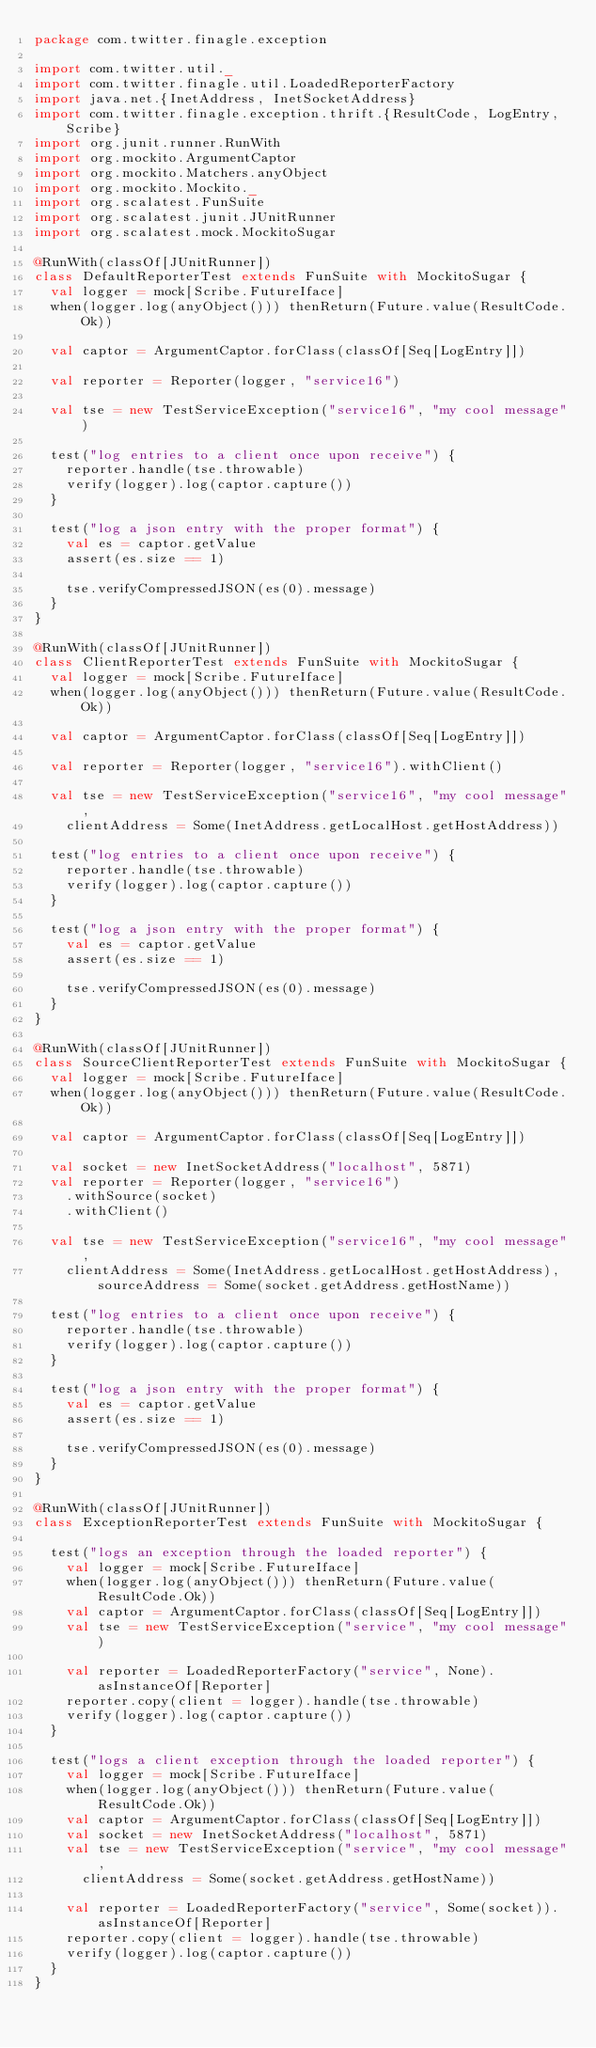<code> <loc_0><loc_0><loc_500><loc_500><_Scala_>package com.twitter.finagle.exception

import com.twitter.util._
import com.twitter.finagle.util.LoadedReporterFactory
import java.net.{InetAddress, InetSocketAddress}
import com.twitter.finagle.exception.thrift.{ResultCode, LogEntry, Scribe}
import org.junit.runner.RunWith
import org.mockito.ArgumentCaptor
import org.mockito.Matchers.anyObject
import org.mockito.Mockito._
import org.scalatest.FunSuite
import org.scalatest.junit.JUnitRunner
import org.scalatest.mock.MockitoSugar

@RunWith(classOf[JUnitRunner])
class DefaultReporterTest extends FunSuite with MockitoSugar {
  val logger = mock[Scribe.FutureIface]
  when(logger.log(anyObject())) thenReturn(Future.value(ResultCode.Ok))

  val captor = ArgumentCaptor.forClass(classOf[Seq[LogEntry]])

  val reporter = Reporter(logger, "service16")

  val tse = new TestServiceException("service16", "my cool message")

  test("log entries to a client once upon receive") {
    reporter.handle(tse.throwable)
    verify(logger).log(captor.capture())
  }

  test("log a json entry with the proper format") {
    val es = captor.getValue
    assert(es.size == 1)

    tse.verifyCompressedJSON(es(0).message)
  }
}

@RunWith(classOf[JUnitRunner])
class ClientReporterTest extends FunSuite with MockitoSugar {
  val logger = mock[Scribe.FutureIface]
  when(logger.log(anyObject())) thenReturn(Future.value(ResultCode.Ok))

  val captor = ArgumentCaptor.forClass(classOf[Seq[LogEntry]])

  val reporter = Reporter(logger, "service16").withClient()

  val tse = new TestServiceException("service16", "my cool message",
    clientAddress = Some(InetAddress.getLocalHost.getHostAddress))

  test("log entries to a client once upon receive") {
    reporter.handle(tse.throwable)
    verify(logger).log(captor.capture())
  }

  test("log a json entry with the proper format") {
    val es = captor.getValue
    assert(es.size == 1)

    tse.verifyCompressedJSON(es(0).message)
  }
}

@RunWith(classOf[JUnitRunner])
class SourceClientReporterTest extends FunSuite with MockitoSugar {
  val logger = mock[Scribe.FutureIface]
  when(logger.log(anyObject())) thenReturn(Future.value(ResultCode.Ok))

  val captor = ArgumentCaptor.forClass(classOf[Seq[LogEntry]])

  val socket = new InetSocketAddress("localhost", 5871)
  val reporter = Reporter(logger, "service16")
    .withSource(socket)
    .withClient()

  val tse = new TestServiceException("service16", "my cool message",
    clientAddress = Some(InetAddress.getLocalHost.getHostAddress), sourceAddress = Some(socket.getAddress.getHostName))

  test("log entries to a client once upon receive") {
    reporter.handle(tse.throwable)
    verify(logger).log(captor.capture())
  }

  test("log a json entry with the proper format") {
    val es = captor.getValue
    assert(es.size == 1)

    tse.verifyCompressedJSON(es(0).message)
  }
}

@RunWith(classOf[JUnitRunner])
class ExceptionReporterTest extends FunSuite with MockitoSugar {

  test("logs an exception through the loaded reporter") {
    val logger = mock[Scribe.FutureIface]
    when(logger.log(anyObject())) thenReturn(Future.value(ResultCode.Ok))
    val captor = ArgumentCaptor.forClass(classOf[Seq[LogEntry]])
    val tse = new TestServiceException("service", "my cool message")

    val reporter = LoadedReporterFactory("service", None).asInstanceOf[Reporter]
    reporter.copy(client = logger).handle(tse.throwable)
    verify(logger).log(captor.capture())
  }

  test("logs a client exception through the loaded reporter") {
    val logger = mock[Scribe.FutureIface]
    when(logger.log(anyObject())) thenReturn(Future.value(ResultCode.Ok))
    val captor = ArgumentCaptor.forClass(classOf[Seq[LogEntry]])
    val socket = new InetSocketAddress("localhost", 5871)
    val tse = new TestServiceException("service", "my cool message",
      clientAddress = Some(socket.getAddress.getHostName))

    val reporter = LoadedReporterFactory("service", Some(socket)).asInstanceOf[Reporter]
    reporter.copy(client = logger).handle(tse.throwable)
    verify(logger).log(captor.capture())
  }
}
</code> 